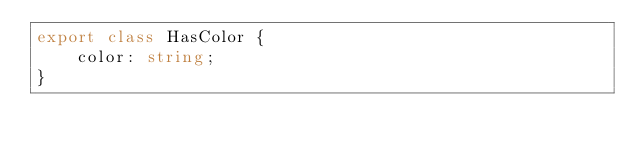Convert code to text. <code><loc_0><loc_0><loc_500><loc_500><_TypeScript_>export class HasColor {
    color: string;
}
</code> 